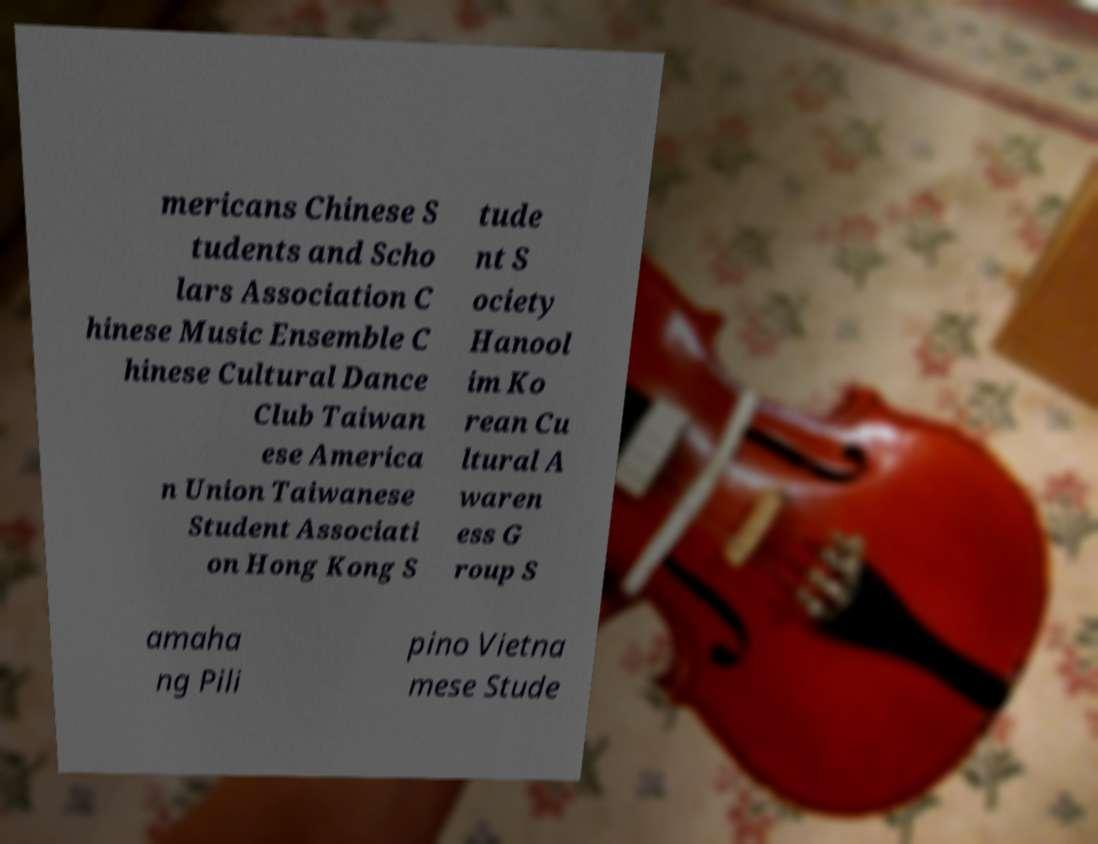Could you extract and type out the text from this image? mericans Chinese S tudents and Scho lars Association C hinese Music Ensemble C hinese Cultural Dance Club Taiwan ese America n Union Taiwanese Student Associati on Hong Kong S tude nt S ociety Hanool im Ko rean Cu ltural A waren ess G roup S amaha ng Pili pino Vietna mese Stude 